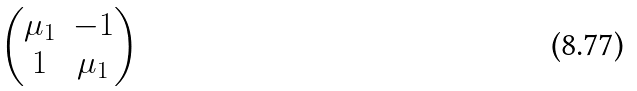Convert formula to latex. <formula><loc_0><loc_0><loc_500><loc_500>\begin{pmatrix} \mu _ { 1 } & - 1 \\ 1 & \mu _ { 1 } \end{pmatrix}</formula> 